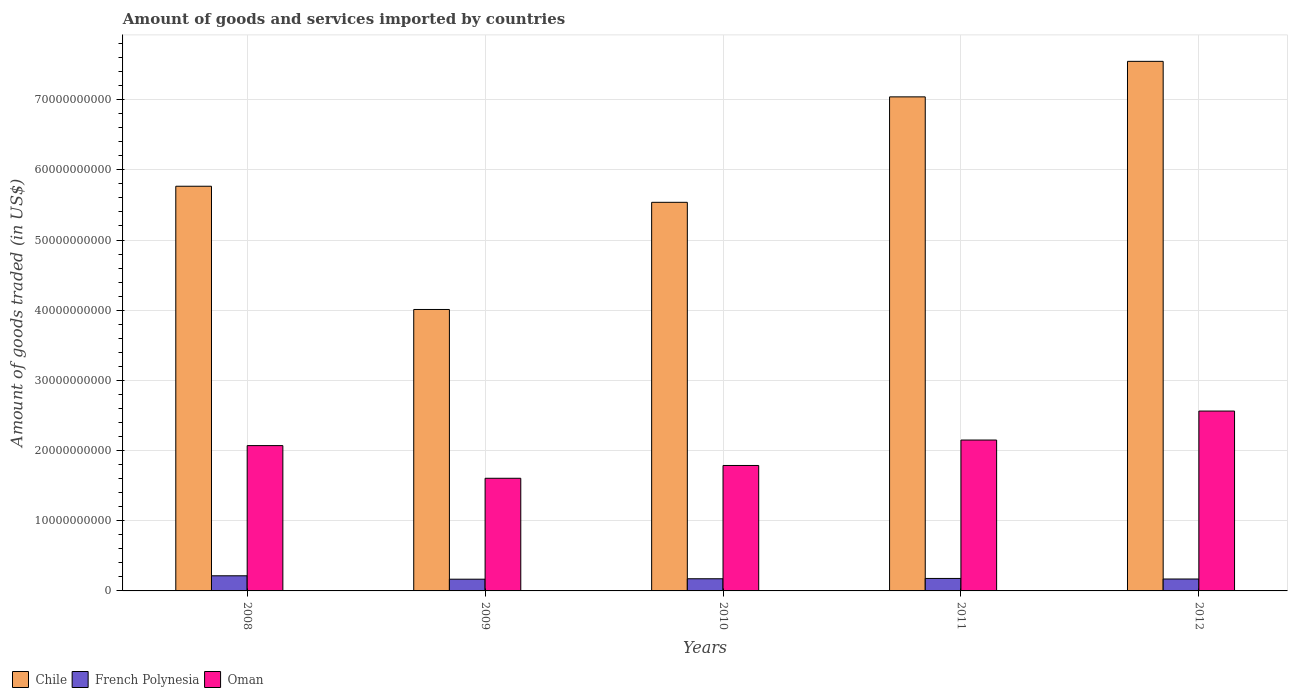How many groups of bars are there?
Your answer should be compact. 5. Are the number of bars per tick equal to the number of legend labels?
Offer a very short reply. Yes. Are the number of bars on each tick of the X-axis equal?
Offer a terse response. Yes. How many bars are there on the 3rd tick from the left?
Ensure brevity in your answer.  3. How many bars are there on the 3rd tick from the right?
Keep it short and to the point. 3. What is the label of the 5th group of bars from the left?
Your answer should be very brief. 2012. In how many cases, is the number of bars for a given year not equal to the number of legend labels?
Give a very brief answer. 0. What is the total amount of goods and services imported in Chile in 2010?
Your response must be concise. 5.54e+1. Across all years, what is the maximum total amount of goods and services imported in French Polynesia?
Your answer should be very brief. 2.16e+09. Across all years, what is the minimum total amount of goods and services imported in Oman?
Keep it short and to the point. 1.61e+1. In which year was the total amount of goods and services imported in Oman minimum?
Keep it short and to the point. 2009. What is the total total amount of goods and services imported in French Polynesia in the graph?
Offer a terse response. 9.04e+09. What is the difference between the total amount of goods and services imported in Oman in 2008 and that in 2012?
Your answer should be compact. -4.92e+09. What is the difference between the total amount of goods and services imported in French Polynesia in 2008 and the total amount of goods and services imported in Chile in 2009?
Your answer should be compact. -3.79e+1. What is the average total amount of goods and services imported in French Polynesia per year?
Your answer should be very brief. 1.81e+09. In the year 2009, what is the difference between the total amount of goods and services imported in Chile and total amount of goods and services imported in Oman?
Make the answer very short. 2.41e+1. What is the ratio of the total amount of goods and services imported in Chile in 2009 to that in 2010?
Your answer should be compact. 0.72. Is the total amount of goods and services imported in Oman in 2009 less than that in 2010?
Provide a succinct answer. Yes. Is the difference between the total amount of goods and services imported in Chile in 2010 and 2012 greater than the difference between the total amount of goods and services imported in Oman in 2010 and 2012?
Make the answer very short. No. What is the difference between the highest and the second highest total amount of goods and services imported in French Polynesia?
Your answer should be very brief. 3.79e+08. What is the difference between the highest and the lowest total amount of goods and services imported in French Polynesia?
Provide a succinct answer. 4.86e+08. What does the 3rd bar from the left in 2009 represents?
Your answer should be very brief. Oman. What does the 1st bar from the right in 2010 represents?
Offer a terse response. Oman. Is it the case that in every year, the sum of the total amount of goods and services imported in Chile and total amount of goods and services imported in French Polynesia is greater than the total amount of goods and services imported in Oman?
Offer a terse response. Yes. How many bars are there?
Provide a succinct answer. 15. Are all the bars in the graph horizontal?
Keep it short and to the point. No. How many years are there in the graph?
Provide a succinct answer. 5. Are the values on the major ticks of Y-axis written in scientific E-notation?
Make the answer very short. No. Does the graph contain grids?
Ensure brevity in your answer.  Yes. What is the title of the graph?
Your response must be concise. Amount of goods and services imported by countries. What is the label or title of the X-axis?
Make the answer very short. Years. What is the label or title of the Y-axis?
Ensure brevity in your answer.  Amount of goods traded (in US$). What is the Amount of goods traded (in US$) in Chile in 2008?
Offer a very short reply. 5.77e+1. What is the Amount of goods traded (in US$) of French Polynesia in 2008?
Ensure brevity in your answer.  2.16e+09. What is the Amount of goods traded (in US$) of Oman in 2008?
Your answer should be very brief. 2.07e+1. What is the Amount of goods traded (in US$) in Chile in 2009?
Provide a short and direct response. 4.01e+1. What is the Amount of goods traded (in US$) of French Polynesia in 2009?
Offer a very short reply. 1.67e+09. What is the Amount of goods traded (in US$) in Oman in 2009?
Your answer should be compact. 1.61e+1. What is the Amount of goods traded (in US$) in Chile in 2010?
Provide a succinct answer. 5.54e+1. What is the Amount of goods traded (in US$) in French Polynesia in 2010?
Your response must be concise. 1.73e+09. What is the Amount of goods traded (in US$) in Oman in 2010?
Keep it short and to the point. 1.79e+1. What is the Amount of goods traded (in US$) of Chile in 2011?
Provide a succinct answer. 7.04e+1. What is the Amount of goods traded (in US$) of French Polynesia in 2011?
Make the answer very short. 1.78e+09. What is the Amount of goods traded (in US$) of Oman in 2011?
Your answer should be very brief. 2.15e+1. What is the Amount of goods traded (in US$) of Chile in 2012?
Keep it short and to the point. 7.55e+1. What is the Amount of goods traded (in US$) in French Polynesia in 2012?
Your response must be concise. 1.70e+09. What is the Amount of goods traded (in US$) of Oman in 2012?
Keep it short and to the point. 2.56e+1. Across all years, what is the maximum Amount of goods traded (in US$) of Chile?
Your answer should be very brief. 7.55e+1. Across all years, what is the maximum Amount of goods traded (in US$) in French Polynesia?
Your answer should be very brief. 2.16e+09. Across all years, what is the maximum Amount of goods traded (in US$) in Oman?
Your response must be concise. 2.56e+1. Across all years, what is the minimum Amount of goods traded (in US$) in Chile?
Provide a succinct answer. 4.01e+1. Across all years, what is the minimum Amount of goods traded (in US$) of French Polynesia?
Offer a terse response. 1.67e+09. Across all years, what is the minimum Amount of goods traded (in US$) in Oman?
Provide a succinct answer. 1.61e+1. What is the total Amount of goods traded (in US$) in Chile in the graph?
Your answer should be compact. 2.99e+11. What is the total Amount of goods traded (in US$) of French Polynesia in the graph?
Offer a terse response. 9.04e+09. What is the total Amount of goods traded (in US$) in Oman in the graph?
Offer a very short reply. 1.02e+11. What is the difference between the Amount of goods traded (in US$) in Chile in 2008 and that in 2009?
Make the answer very short. 1.76e+1. What is the difference between the Amount of goods traded (in US$) in French Polynesia in 2008 and that in 2009?
Offer a terse response. 4.86e+08. What is the difference between the Amount of goods traded (in US$) of Oman in 2008 and that in 2009?
Your response must be concise. 4.66e+09. What is the difference between the Amount of goods traded (in US$) in Chile in 2008 and that in 2010?
Your answer should be very brief. 2.29e+09. What is the difference between the Amount of goods traded (in US$) of French Polynesia in 2008 and that in 2010?
Offer a terse response. 4.25e+08. What is the difference between the Amount of goods traded (in US$) in Oman in 2008 and that in 2010?
Offer a terse response. 2.83e+09. What is the difference between the Amount of goods traded (in US$) of Chile in 2008 and that in 2011?
Provide a succinct answer. -1.27e+1. What is the difference between the Amount of goods traded (in US$) of French Polynesia in 2008 and that in 2011?
Provide a succinct answer. 3.79e+08. What is the difference between the Amount of goods traded (in US$) of Oman in 2008 and that in 2011?
Offer a terse response. -7.91e+08. What is the difference between the Amount of goods traded (in US$) of Chile in 2008 and that in 2012?
Provide a short and direct response. -1.78e+1. What is the difference between the Amount of goods traded (in US$) in French Polynesia in 2008 and that in 2012?
Offer a terse response. 4.59e+08. What is the difference between the Amount of goods traded (in US$) in Oman in 2008 and that in 2012?
Your answer should be very brief. -4.92e+09. What is the difference between the Amount of goods traded (in US$) of Chile in 2009 and that in 2010?
Give a very brief answer. -1.53e+1. What is the difference between the Amount of goods traded (in US$) of French Polynesia in 2009 and that in 2010?
Give a very brief answer. -6.06e+07. What is the difference between the Amount of goods traded (in US$) in Oman in 2009 and that in 2010?
Offer a terse response. -1.82e+09. What is the difference between the Amount of goods traded (in US$) of Chile in 2009 and that in 2011?
Give a very brief answer. -3.03e+1. What is the difference between the Amount of goods traded (in US$) of French Polynesia in 2009 and that in 2011?
Give a very brief answer. -1.06e+08. What is the difference between the Amount of goods traded (in US$) of Oman in 2009 and that in 2011?
Your answer should be very brief. -5.45e+09. What is the difference between the Amount of goods traded (in US$) of Chile in 2009 and that in 2012?
Your answer should be very brief. -3.54e+1. What is the difference between the Amount of goods traded (in US$) in French Polynesia in 2009 and that in 2012?
Offer a terse response. -2.66e+07. What is the difference between the Amount of goods traded (in US$) in Oman in 2009 and that in 2012?
Provide a short and direct response. -9.58e+09. What is the difference between the Amount of goods traded (in US$) of Chile in 2010 and that in 2011?
Make the answer very short. -1.50e+1. What is the difference between the Amount of goods traded (in US$) of French Polynesia in 2010 and that in 2011?
Make the answer very short. -4.57e+07. What is the difference between the Amount of goods traded (in US$) in Oman in 2010 and that in 2011?
Make the answer very short. -3.62e+09. What is the difference between the Amount of goods traded (in US$) in Chile in 2010 and that in 2012?
Your response must be concise. -2.01e+1. What is the difference between the Amount of goods traded (in US$) in French Polynesia in 2010 and that in 2012?
Your response must be concise. 3.40e+07. What is the difference between the Amount of goods traded (in US$) of Oman in 2010 and that in 2012?
Give a very brief answer. -7.75e+09. What is the difference between the Amount of goods traded (in US$) in Chile in 2011 and that in 2012?
Give a very brief answer. -5.06e+09. What is the difference between the Amount of goods traded (in US$) of French Polynesia in 2011 and that in 2012?
Keep it short and to the point. 7.98e+07. What is the difference between the Amount of goods traded (in US$) of Oman in 2011 and that in 2012?
Your answer should be very brief. -4.13e+09. What is the difference between the Amount of goods traded (in US$) of Chile in 2008 and the Amount of goods traded (in US$) of French Polynesia in 2009?
Offer a very short reply. 5.60e+1. What is the difference between the Amount of goods traded (in US$) of Chile in 2008 and the Amount of goods traded (in US$) of Oman in 2009?
Offer a very short reply. 4.16e+1. What is the difference between the Amount of goods traded (in US$) in French Polynesia in 2008 and the Amount of goods traded (in US$) in Oman in 2009?
Provide a short and direct response. -1.39e+1. What is the difference between the Amount of goods traded (in US$) in Chile in 2008 and the Amount of goods traded (in US$) in French Polynesia in 2010?
Offer a very short reply. 5.59e+1. What is the difference between the Amount of goods traded (in US$) of Chile in 2008 and the Amount of goods traded (in US$) of Oman in 2010?
Provide a succinct answer. 3.98e+1. What is the difference between the Amount of goods traded (in US$) of French Polynesia in 2008 and the Amount of goods traded (in US$) of Oman in 2010?
Provide a short and direct response. -1.57e+1. What is the difference between the Amount of goods traded (in US$) in Chile in 2008 and the Amount of goods traded (in US$) in French Polynesia in 2011?
Your answer should be compact. 5.59e+1. What is the difference between the Amount of goods traded (in US$) of Chile in 2008 and the Amount of goods traded (in US$) of Oman in 2011?
Keep it short and to the point. 3.62e+1. What is the difference between the Amount of goods traded (in US$) in French Polynesia in 2008 and the Amount of goods traded (in US$) in Oman in 2011?
Give a very brief answer. -1.93e+1. What is the difference between the Amount of goods traded (in US$) in Chile in 2008 and the Amount of goods traded (in US$) in French Polynesia in 2012?
Provide a succinct answer. 5.60e+1. What is the difference between the Amount of goods traded (in US$) of Chile in 2008 and the Amount of goods traded (in US$) of Oman in 2012?
Your answer should be compact. 3.20e+1. What is the difference between the Amount of goods traded (in US$) in French Polynesia in 2008 and the Amount of goods traded (in US$) in Oman in 2012?
Keep it short and to the point. -2.35e+1. What is the difference between the Amount of goods traded (in US$) in Chile in 2009 and the Amount of goods traded (in US$) in French Polynesia in 2010?
Your answer should be compact. 3.84e+1. What is the difference between the Amount of goods traded (in US$) of Chile in 2009 and the Amount of goods traded (in US$) of Oman in 2010?
Provide a succinct answer. 2.22e+1. What is the difference between the Amount of goods traded (in US$) in French Polynesia in 2009 and the Amount of goods traded (in US$) in Oman in 2010?
Your answer should be very brief. -1.62e+1. What is the difference between the Amount of goods traded (in US$) of Chile in 2009 and the Amount of goods traded (in US$) of French Polynesia in 2011?
Offer a very short reply. 3.83e+1. What is the difference between the Amount of goods traded (in US$) of Chile in 2009 and the Amount of goods traded (in US$) of Oman in 2011?
Offer a very short reply. 1.86e+1. What is the difference between the Amount of goods traded (in US$) of French Polynesia in 2009 and the Amount of goods traded (in US$) of Oman in 2011?
Provide a succinct answer. -1.98e+1. What is the difference between the Amount of goods traded (in US$) of Chile in 2009 and the Amount of goods traded (in US$) of French Polynesia in 2012?
Provide a short and direct response. 3.84e+1. What is the difference between the Amount of goods traded (in US$) in Chile in 2009 and the Amount of goods traded (in US$) in Oman in 2012?
Provide a short and direct response. 1.45e+1. What is the difference between the Amount of goods traded (in US$) in French Polynesia in 2009 and the Amount of goods traded (in US$) in Oman in 2012?
Your answer should be very brief. -2.40e+1. What is the difference between the Amount of goods traded (in US$) of Chile in 2010 and the Amount of goods traded (in US$) of French Polynesia in 2011?
Ensure brevity in your answer.  5.36e+1. What is the difference between the Amount of goods traded (in US$) of Chile in 2010 and the Amount of goods traded (in US$) of Oman in 2011?
Give a very brief answer. 3.39e+1. What is the difference between the Amount of goods traded (in US$) in French Polynesia in 2010 and the Amount of goods traded (in US$) in Oman in 2011?
Ensure brevity in your answer.  -1.98e+1. What is the difference between the Amount of goods traded (in US$) in Chile in 2010 and the Amount of goods traded (in US$) in French Polynesia in 2012?
Make the answer very short. 5.37e+1. What is the difference between the Amount of goods traded (in US$) of Chile in 2010 and the Amount of goods traded (in US$) of Oman in 2012?
Keep it short and to the point. 2.97e+1. What is the difference between the Amount of goods traded (in US$) in French Polynesia in 2010 and the Amount of goods traded (in US$) in Oman in 2012?
Provide a short and direct response. -2.39e+1. What is the difference between the Amount of goods traded (in US$) in Chile in 2011 and the Amount of goods traded (in US$) in French Polynesia in 2012?
Provide a succinct answer. 6.87e+1. What is the difference between the Amount of goods traded (in US$) of Chile in 2011 and the Amount of goods traded (in US$) of Oman in 2012?
Provide a succinct answer. 4.48e+1. What is the difference between the Amount of goods traded (in US$) of French Polynesia in 2011 and the Amount of goods traded (in US$) of Oman in 2012?
Provide a succinct answer. -2.39e+1. What is the average Amount of goods traded (in US$) of Chile per year?
Give a very brief answer. 5.98e+1. What is the average Amount of goods traded (in US$) in French Polynesia per year?
Provide a short and direct response. 1.81e+09. What is the average Amount of goods traded (in US$) of Oman per year?
Keep it short and to the point. 2.04e+1. In the year 2008, what is the difference between the Amount of goods traded (in US$) in Chile and Amount of goods traded (in US$) in French Polynesia?
Offer a terse response. 5.55e+1. In the year 2008, what is the difference between the Amount of goods traded (in US$) in Chile and Amount of goods traded (in US$) in Oman?
Provide a succinct answer. 3.70e+1. In the year 2008, what is the difference between the Amount of goods traded (in US$) in French Polynesia and Amount of goods traded (in US$) in Oman?
Your response must be concise. -1.85e+1. In the year 2009, what is the difference between the Amount of goods traded (in US$) in Chile and Amount of goods traded (in US$) in French Polynesia?
Offer a very short reply. 3.84e+1. In the year 2009, what is the difference between the Amount of goods traded (in US$) in Chile and Amount of goods traded (in US$) in Oman?
Your answer should be compact. 2.41e+1. In the year 2009, what is the difference between the Amount of goods traded (in US$) in French Polynesia and Amount of goods traded (in US$) in Oman?
Give a very brief answer. -1.44e+1. In the year 2010, what is the difference between the Amount of goods traded (in US$) of Chile and Amount of goods traded (in US$) of French Polynesia?
Offer a terse response. 5.36e+1. In the year 2010, what is the difference between the Amount of goods traded (in US$) in Chile and Amount of goods traded (in US$) in Oman?
Your response must be concise. 3.75e+1. In the year 2010, what is the difference between the Amount of goods traded (in US$) in French Polynesia and Amount of goods traded (in US$) in Oman?
Your answer should be very brief. -1.61e+1. In the year 2011, what is the difference between the Amount of goods traded (in US$) of Chile and Amount of goods traded (in US$) of French Polynesia?
Your response must be concise. 6.86e+1. In the year 2011, what is the difference between the Amount of goods traded (in US$) of Chile and Amount of goods traded (in US$) of Oman?
Provide a succinct answer. 4.89e+1. In the year 2011, what is the difference between the Amount of goods traded (in US$) in French Polynesia and Amount of goods traded (in US$) in Oman?
Ensure brevity in your answer.  -1.97e+1. In the year 2012, what is the difference between the Amount of goods traded (in US$) of Chile and Amount of goods traded (in US$) of French Polynesia?
Your answer should be compact. 7.38e+1. In the year 2012, what is the difference between the Amount of goods traded (in US$) of Chile and Amount of goods traded (in US$) of Oman?
Make the answer very short. 4.98e+1. In the year 2012, what is the difference between the Amount of goods traded (in US$) of French Polynesia and Amount of goods traded (in US$) of Oman?
Ensure brevity in your answer.  -2.39e+1. What is the ratio of the Amount of goods traded (in US$) of Chile in 2008 to that in 2009?
Your answer should be very brief. 1.44. What is the ratio of the Amount of goods traded (in US$) of French Polynesia in 2008 to that in 2009?
Your answer should be compact. 1.29. What is the ratio of the Amount of goods traded (in US$) in Oman in 2008 to that in 2009?
Offer a very short reply. 1.29. What is the ratio of the Amount of goods traded (in US$) in Chile in 2008 to that in 2010?
Your answer should be very brief. 1.04. What is the ratio of the Amount of goods traded (in US$) of French Polynesia in 2008 to that in 2010?
Offer a terse response. 1.25. What is the ratio of the Amount of goods traded (in US$) in Oman in 2008 to that in 2010?
Ensure brevity in your answer.  1.16. What is the ratio of the Amount of goods traded (in US$) of Chile in 2008 to that in 2011?
Your response must be concise. 0.82. What is the ratio of the Amount of goods traded (in US$) of French Polynesia in 2008 to that in 2011?
Give a very brief answer. 1.21. What is the ratio of the Amount of goods traded (in US$) in Oman in 2008 to that in 2011?
Make the answer very short. 0.96. What is the ratio of the Amount of goods traded (in US$) of Chile in 2008 to that in 2012?
Ensure brevity in your answer.  0.76. What is the ratio of the Amount of goods traded (in US$) in French Polynesia in 2008 to that in 2012?
Offer a terse response. 1.27. What is the ratio of the Amount of goods traded (in US$) in Oman in 2008 to that in 2012?
Your answer should be compact. 0.81. What is the ratio of the Amount of goods traded (in US$) in Chile in 2009 to that in 2010?
Give a very brief answer. 0.72. What is the ratio of the Amount of goods traded (in US$) in French Polynesia in 2009 to that in 2010?
Make the answer very short. 0.96. What is the ratio of the Amount of goods traded (in US$) in Oman in 2009 to that in 2010?
Provide a short and direct response. 0.9. What is the ratio of the Amount of goods traded (in US$) of Chile in 2009 to that in 2011?
Keep it short and to the point. 0.57. What is the ratio of the Amount of goods traded (in US$) in French Polynesia in 2009 to that in 2011?
Offer a very short reply. 0.94. What is the ratio of the Amount of goods traded (in US$) in Oman in 2009 to that in 2011?
Offer a very short reply. 0.75. What is the ratio of the Amount of goods traded (in US$) of Chile in 2009 to that in 2012?
Your answer should be compact. 0.53. What is the ratio of the Amount of goods traded (in US$) in French Polynesia in 2009 to that in 2012?
Provide a succinct answer. 0.98. What is the ratio of the Amount of goods traded (in US$) in Oman in 2009 to that in 2012?
Your answer should be compact. 0.63. What is the ratio of the Amount of goods traded (in US$) of Chile in 2010 to that in 2011?
Ensure brevity in your answer.  0.79. What is the ratio of the Amount of goods traded (in US$) in French Polynesia in 2010 to that in 2011?
Ensure brevity in your answer.  0.97. What is the ratio of the Amount of goods traded (in US$) in Oman in 2010 to that in 2011?
Provide a short and direct response. 0.83. What is the ratio of the Amount of goods traded (in US$) of Chile in 2010 to that in 2012?
Provide a short and direct response. 0.73. What is the ratio of the Amount of goods traded (in US$) of French Polynesia in 2010 to that in 2012?
Provide a short and direct response. 1.02. What is the ratio of the Amount of goods traded (in US$) in Oman in 2010 to that in 2012?
Keep it short and to the point. 0.7. What is the ratio of the Amount of goods traded (in US$) of Chile in 2011 to that in 2012?
Ensure brevity in your answer.  0.93. What is the ratio of the Amount of goods traded (in US$) in French Polynesia in 2011 to that in 2012?
Your answer should be very brief. 1.05. What is the ratio of the Amount of goods traded (in US$) of Oman in 2011 to that in 2012?
Your answer should be compact. 0.84. What is the difference between the highest and the second highest Amount of goods traded (in US$) in Chile?
Provide a short and direct response. 5.06e+09. What is the difference between the highest and the second highest Amount of goods traded (in US$) of French Polynesia?
Your response must be concise. 3.79e+08. What is the difference between the highest and the second highest Amount of goods traded (in US$) of Oman?
Offer a terse response. 4.13e+09. What is the difference between the highest and the lowest Amount of goods traded (in US$) of Chile?
Provide a succinct answer. 3.54e+1. What is the difference between the highest and the lowest Amount of goods traded (in US$) in French Polynesia?
Your response must be concise. 4.86e+08. What is the difference between the highest and the lowest Amount of goods traded (in US$) in Oman?
Give a very brief answer. 9.58e+09. 